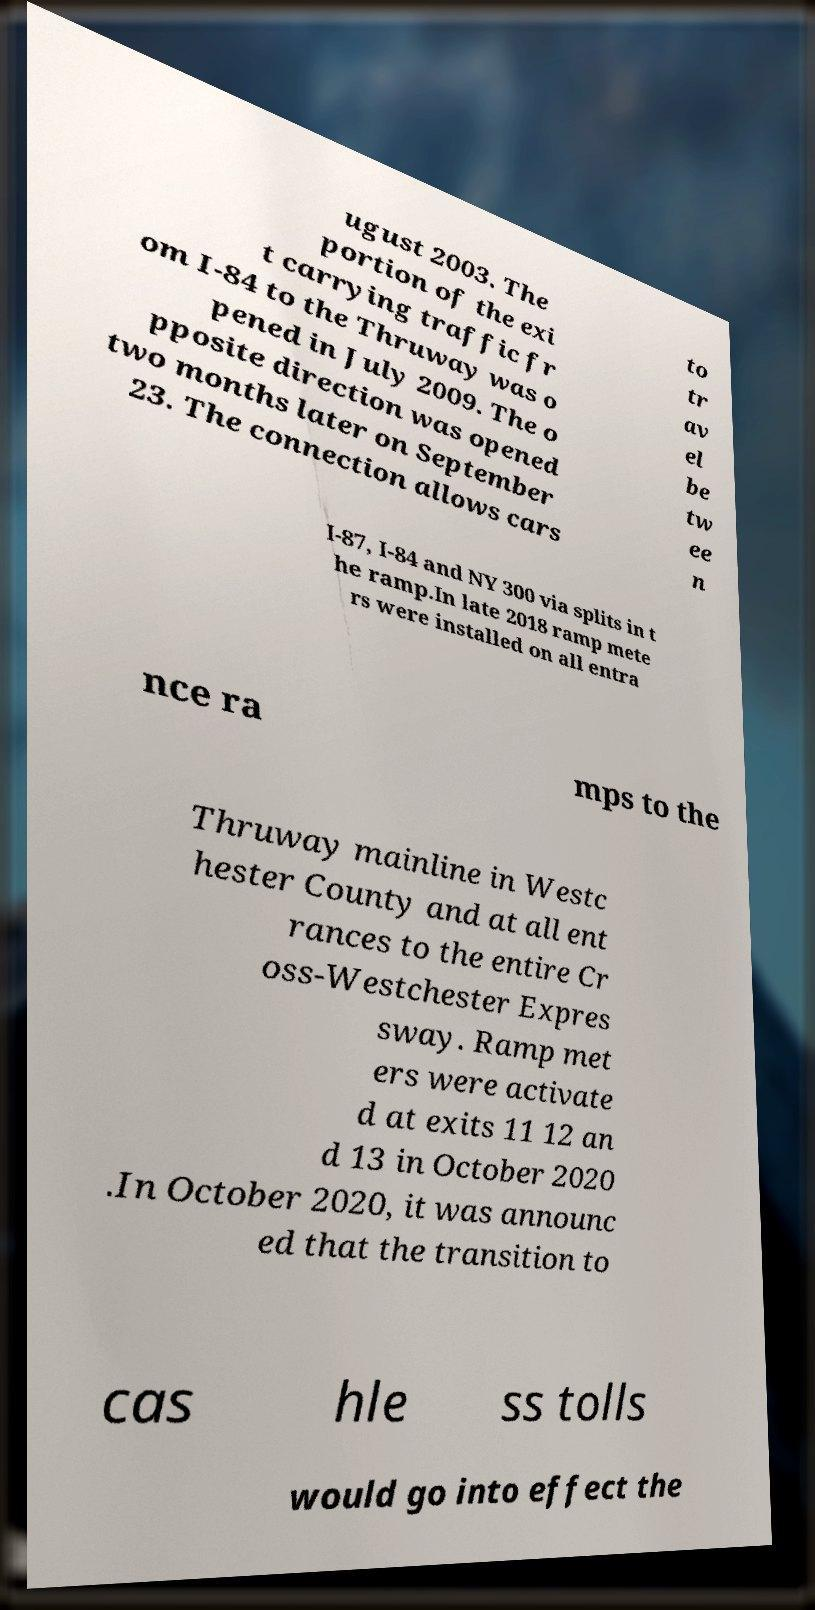Can you accurately transcribe the text from the provided image for me? ugust 2003. The portion of the exi t carrying traffic fr om I-84 to the Thruway was o pened in July 2009. The o pposite direction was opened two months later on September 23. The connection allows cars to tr av el be tw ee n I-87, I-84 and NY 300 via splits in t he ramp.In late 2018 ramp mete rs were installed on all entra nce ra mps to the Thruway mainline in Westc hester County and at all ent rances to the entire Cr oss-Westchester Expres sway. Ramp met ers were activate d at exits 11 12 an d 13 in October 2020 .In October 2020, it was announc ed that the transition to cas hle ss tolls would go into effect the 